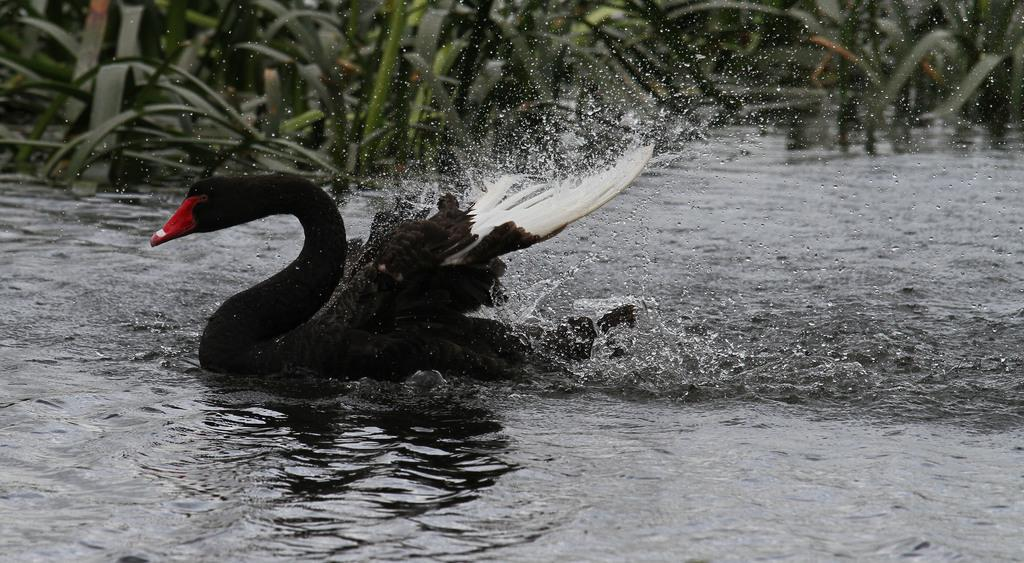What animal is present in the image? There is a swan in the image. Where is the swan located? The swan is in the water. What can be seen in the background of the image? There are plants visible in the background of the image. How many times did the swan apply the brake in the image? There is no reference to a brake in the image, as swans do not have brakes. 